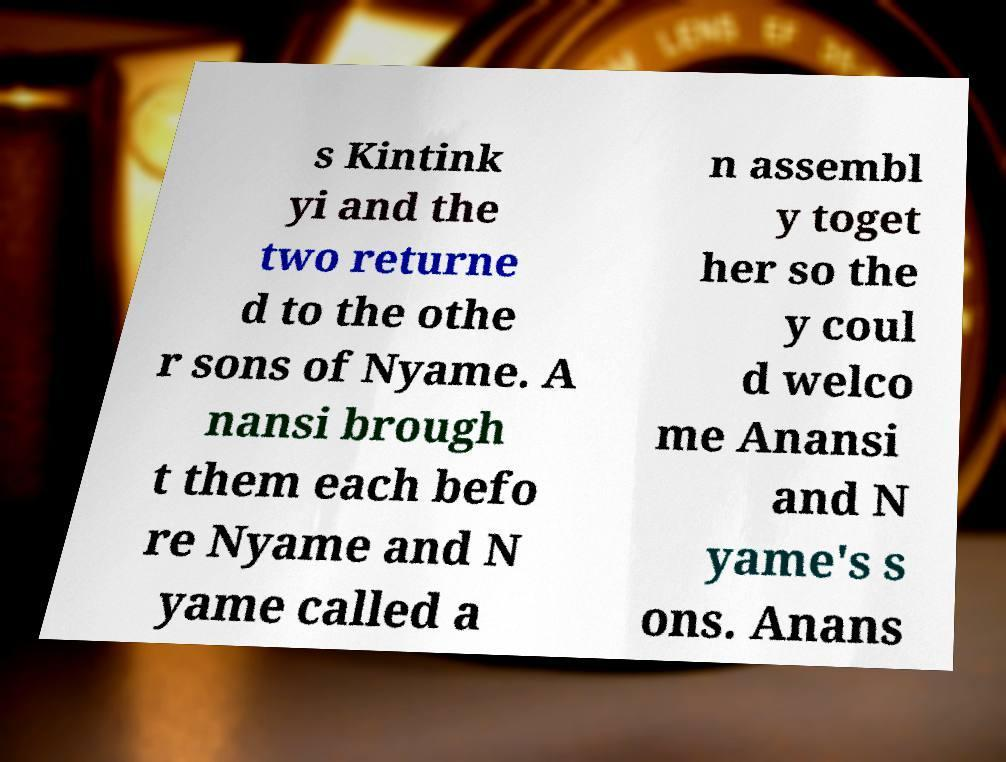Please read and relay the text visible in this image. What does it say? s Kintink yi and the two returne d to the othe r sons of Nyame. A nansi brough t them each befo re Nyame and N yame called a n assembl y toget her so the y coul d welco me Anansi and N yame's s ons. Anans 